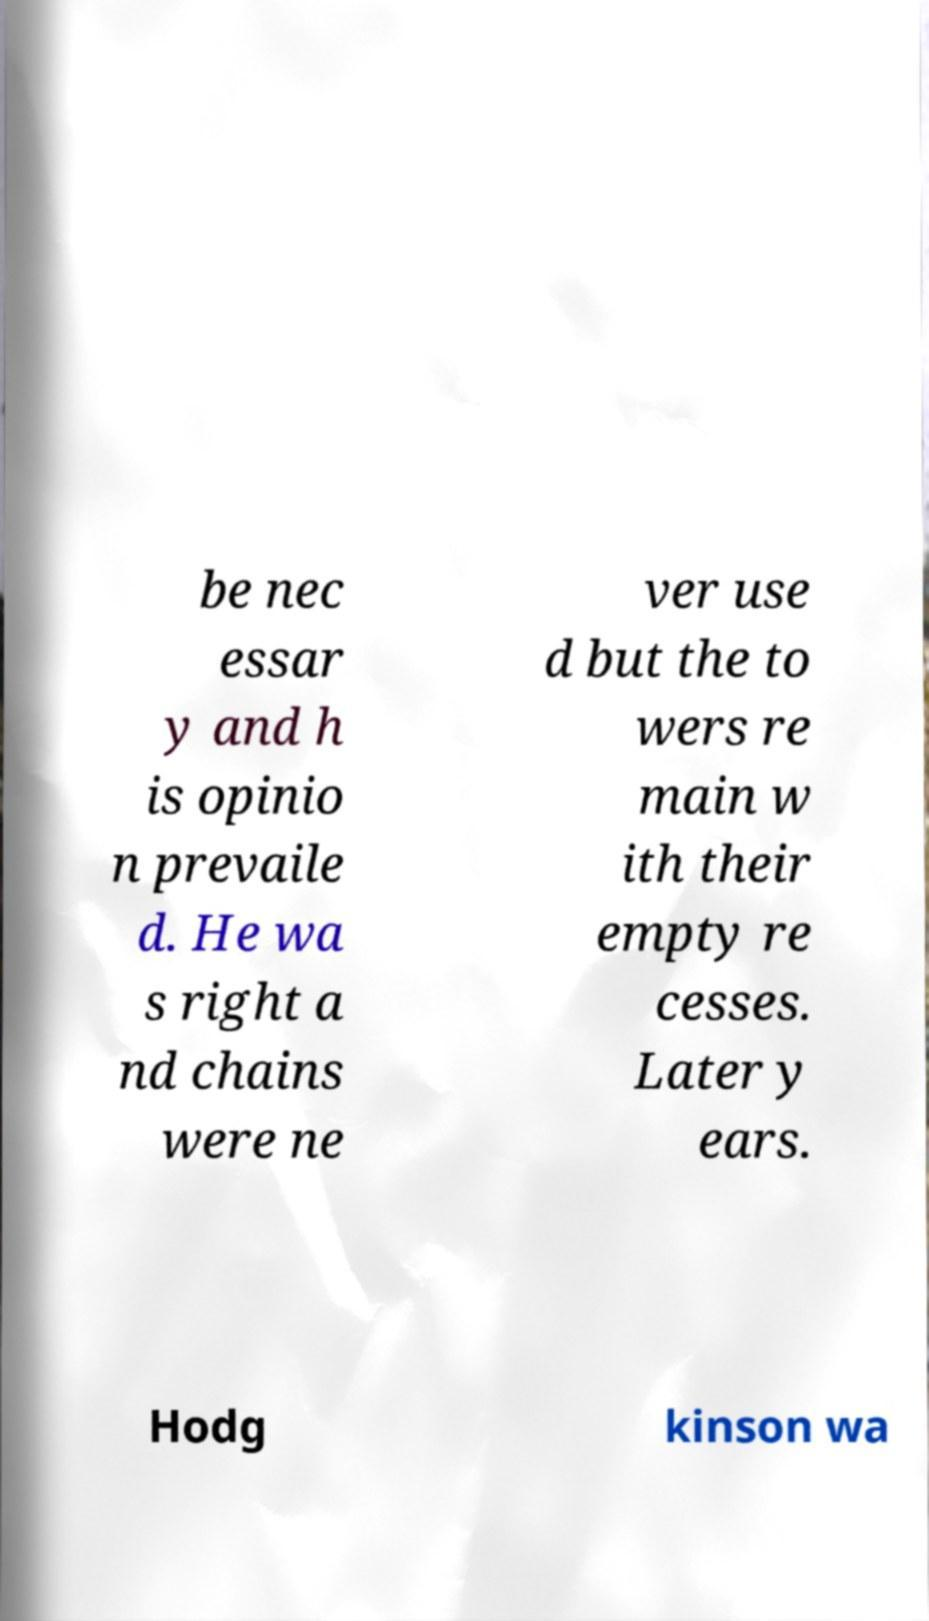There's text embedded in this image that I need extracted. Can you transcribe it verbatim? be nec essar y and h is opinio n prevaile d. He wa s right a nd chains were ne ver use d but the to wers re main w ith their empty re cesses. Later y ears. Hodg kinson wa 